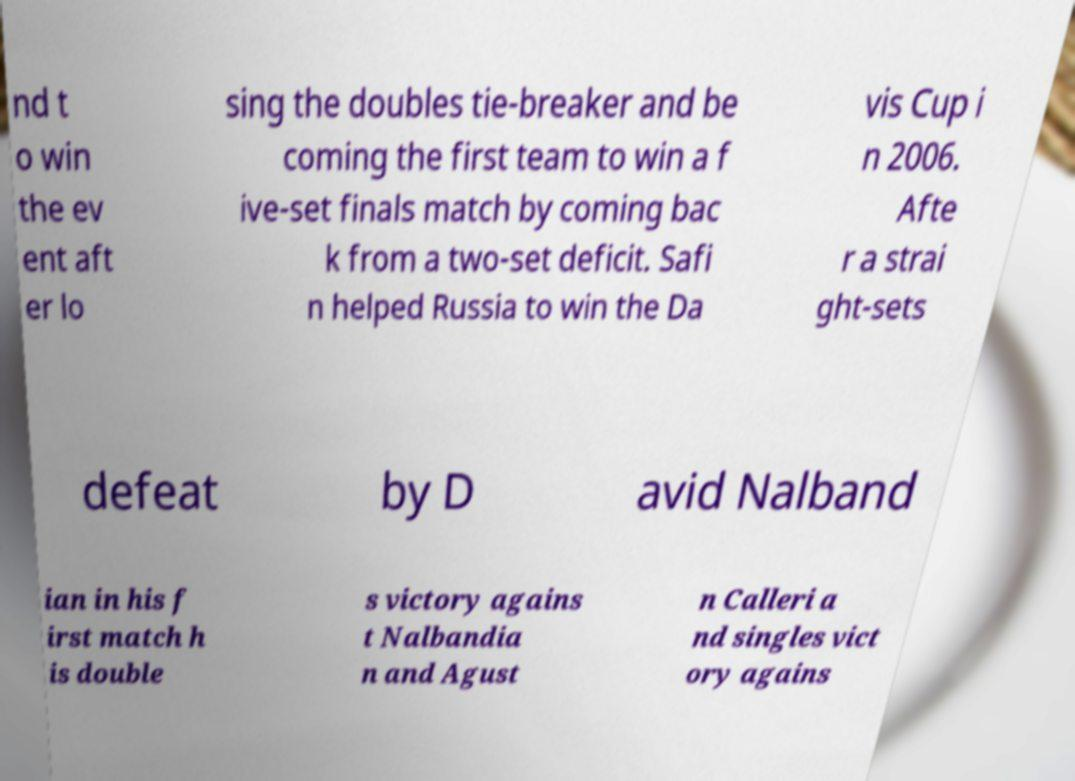There's text embedded in this image that I need extracted. Can you transcribe it verbatim? nd t o win the ev ent aft er lo sing the doubles tie-breaker and be coming the first team to win a f ive-set finals match by coming bac k from a two-set deficit. Safi n helped Russia to win the Da vis Cup i n 2006. Afte r a strai ght-sets defeat by D avid Nalband ian in his f irst match h is double s victory agains t Nalbandia n and Agust n Calleri a nd singles vict ory agains 